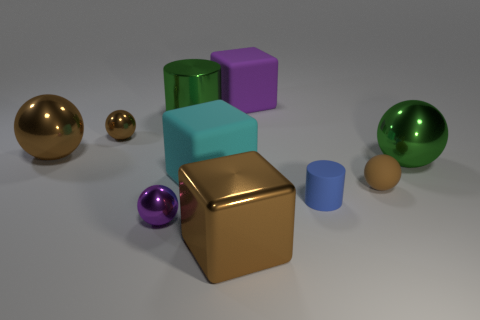Can you describe the lighting in this scene? The lighting in this scene appears to be soft and diffused, likely coming from a source above and slightly in front of the objects. There are soft shadows directly under and to the sides of the objects which add depth and dimension to the scene without creating harsh contrasts. 